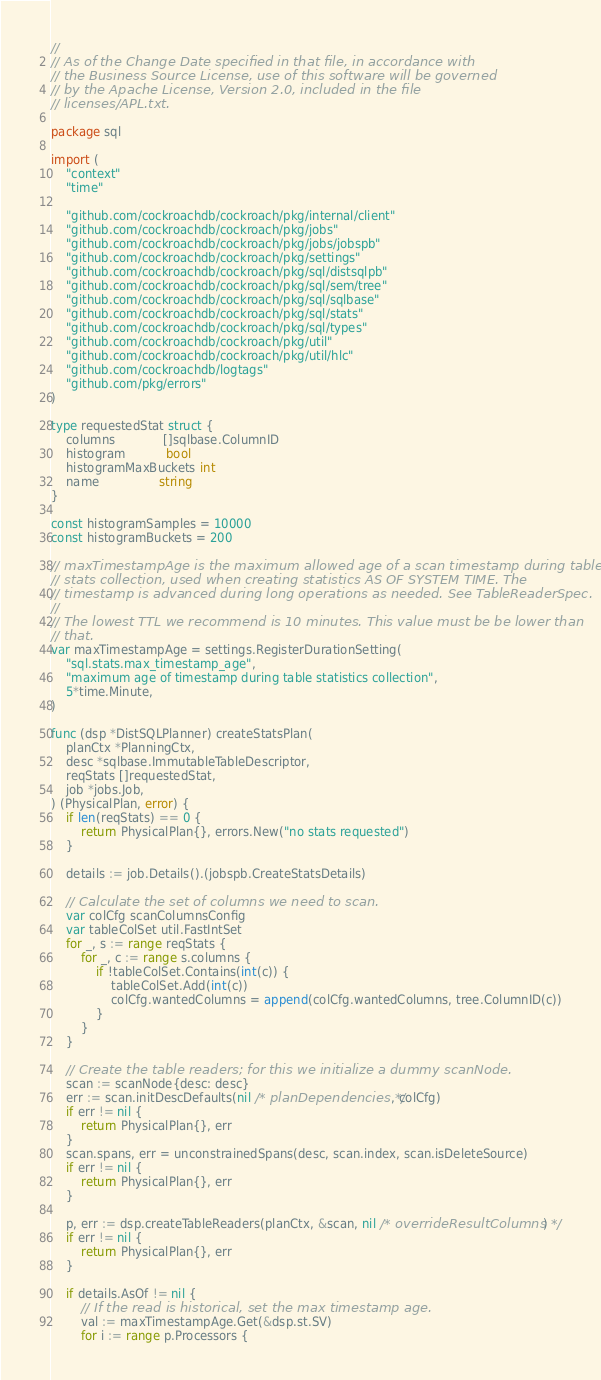<code> <loc_0><loc_0><loc_500><loc_500><_Go_>//
// As of the Change Date specified in that file, in accordance with
// the Business Source License, use of this software will be governed
// by the Apache License, Version 2.0, included in the file
// licenses/APL.txt.

package sql

import (
	"context"
	"time"

	"github.com/cockroachdb/cockroach/pkg/internal/client"
	"github.com/cockroachdb/cockroach/pkg/jobs"
	"github.com/cockroachdb/cockroach/pkg/jobs/jobspb"
	"github.com/cockroachdb/cockroach/pkg/settings"
	"github.com/cockroachdb/cockroach/pkg/sql/distsqlpb"
	"github.com/cockroachdb/cockroach/pkg/sql/sem/tree"
	"github.com/cockroachdb/cockroach/pkg/sql/sqlbase"
	"github.com/cockroachdb/cockroach/pkg/sql/stats"
	"github.com/cockroachdb/cockroach/pkg/sql/types"
	"github.com/cockroachdb/cockroach/pkg/util"
	"github.com/cockroachdb/cockroach/pkg/util/hlc"
	"github.com/cockroachdb/logtags"
	"github.com/pkg/errors"
)

type requestedStat struct {
	columns             []sqlbase.ColumnID
	histogram           bool
	histogramMaxBuckets int
	name                string
}

const histogramSamples = 10000
const histogramBuckets = 200

// maxTimestampAge is the maximum allowed age of a scan timestamp during table
// stats collection, used when creating statistics AS OF SYSTEM TIME. The
// timestamp is advanced during long operations as needed. See TableReaderSpec.
//
// The lowest TTL we recommend is 10 minutes. This value must be be lower than
// that.
var maxTimestampAge = settings.RegisterDurationSetting(
	"sql.stats.max_timestamp_age",
	"maximum age of timestamp during table statistics collection",
	5*time.Minute,
)

func (dsp *DistSQLPlanner) createStatsPlan(
	planCtx *PlanningCtx,
	desc *sqlbase.ImmutableTableDescriptor,
	reqStats []requestedStat,
	job *jobs.Job,
) (PhysicalPlan, error) {
	if len(reqStats) == 0 {
		return PhysicalPlan{}, errors.New("no stats requested")
	}

	details := job.Details().(jobspb.CreateStatsDetails)

	// Calculate the set of columns we need to scan.
	var colCfg scanColumnsConfig
	var tableColSet util.FastIntSet
	for _, s := range reqStats {
		for _, c := range s.columns {
			if !tableColSet.Contains(int(c)) {
				tableColSet.Add(int(c))
				colCfg.wantedColumns = append(colCfg.wantedColumns, tree.ColumnID(c))
			}
		}
	}

	// Create the table readers; for this we initialize a dummy scanNode.
	scan := scanNode{desc: desc}
	err := scan.initDescDefaults(nil /* planDependencies */, colCfg)
	if err != nil {
		return PhysicalPlan{}, err
	}
	scan.spans, err = unconstrainedSpans(desc, scan.index, scan.isDeleteSource)
	if err != nil {
		return PhysicalPlan{}, err
	}

	p, err := dsp.createTableReaders(planCtx, &scan, nil /* overrideResultColumns */)
	if err != nil {
		return PhysicalPlan{}, err
	}

	if details.AsOf != nil {
		// If the read is historical, set the max timestamp age.
		val := maxTimestampAge.Get(&dsp.st.SV)
		for i := range p.Processors {</code> 